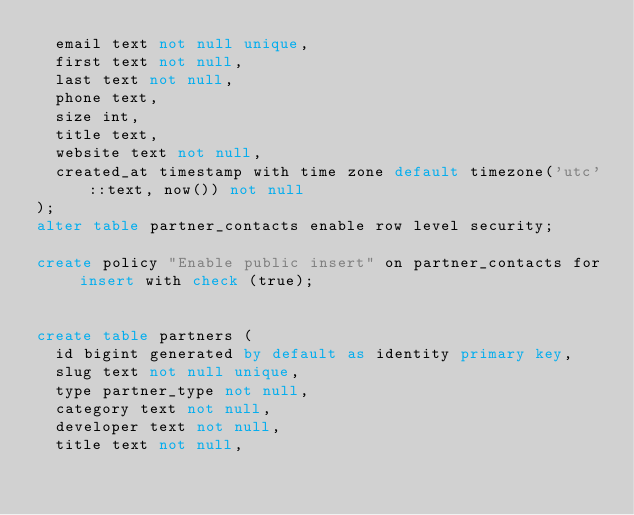<code> <loc_0><loc_0><loc_500><loc_500><_SQL_>  email text not null unique,
  first text not null,
  last text not null,
  phone text,
  size int,
  title text,
  website text not null,
  created_at timestamp with time zone default timezone('utc'::text, now()) not null
);
alter table partner_contacts enable row level security;

create policy "Enable public insert" on partner_contacts for insert with check (true);


create table partners (
  id bigint generated by default as identity primary key,
  slug text not null unique,
  type partner_type not null,
  category text not null,
  developer text not null,
  title text not null,</code> 